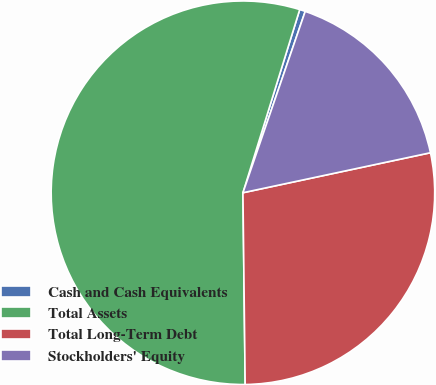<chart> <loc_0><loc_0><loc_500><loc_500><pie_chart><fcel>Cash and Cash Equivalents<fcel>Total Assets<fcel>Total Long-Term Debt<fcel>Stockholders' Equity<nl><fcel>0.48%<fcel>54.97%<fcel>28.16%<fcel>16.39%<nl></chart> 